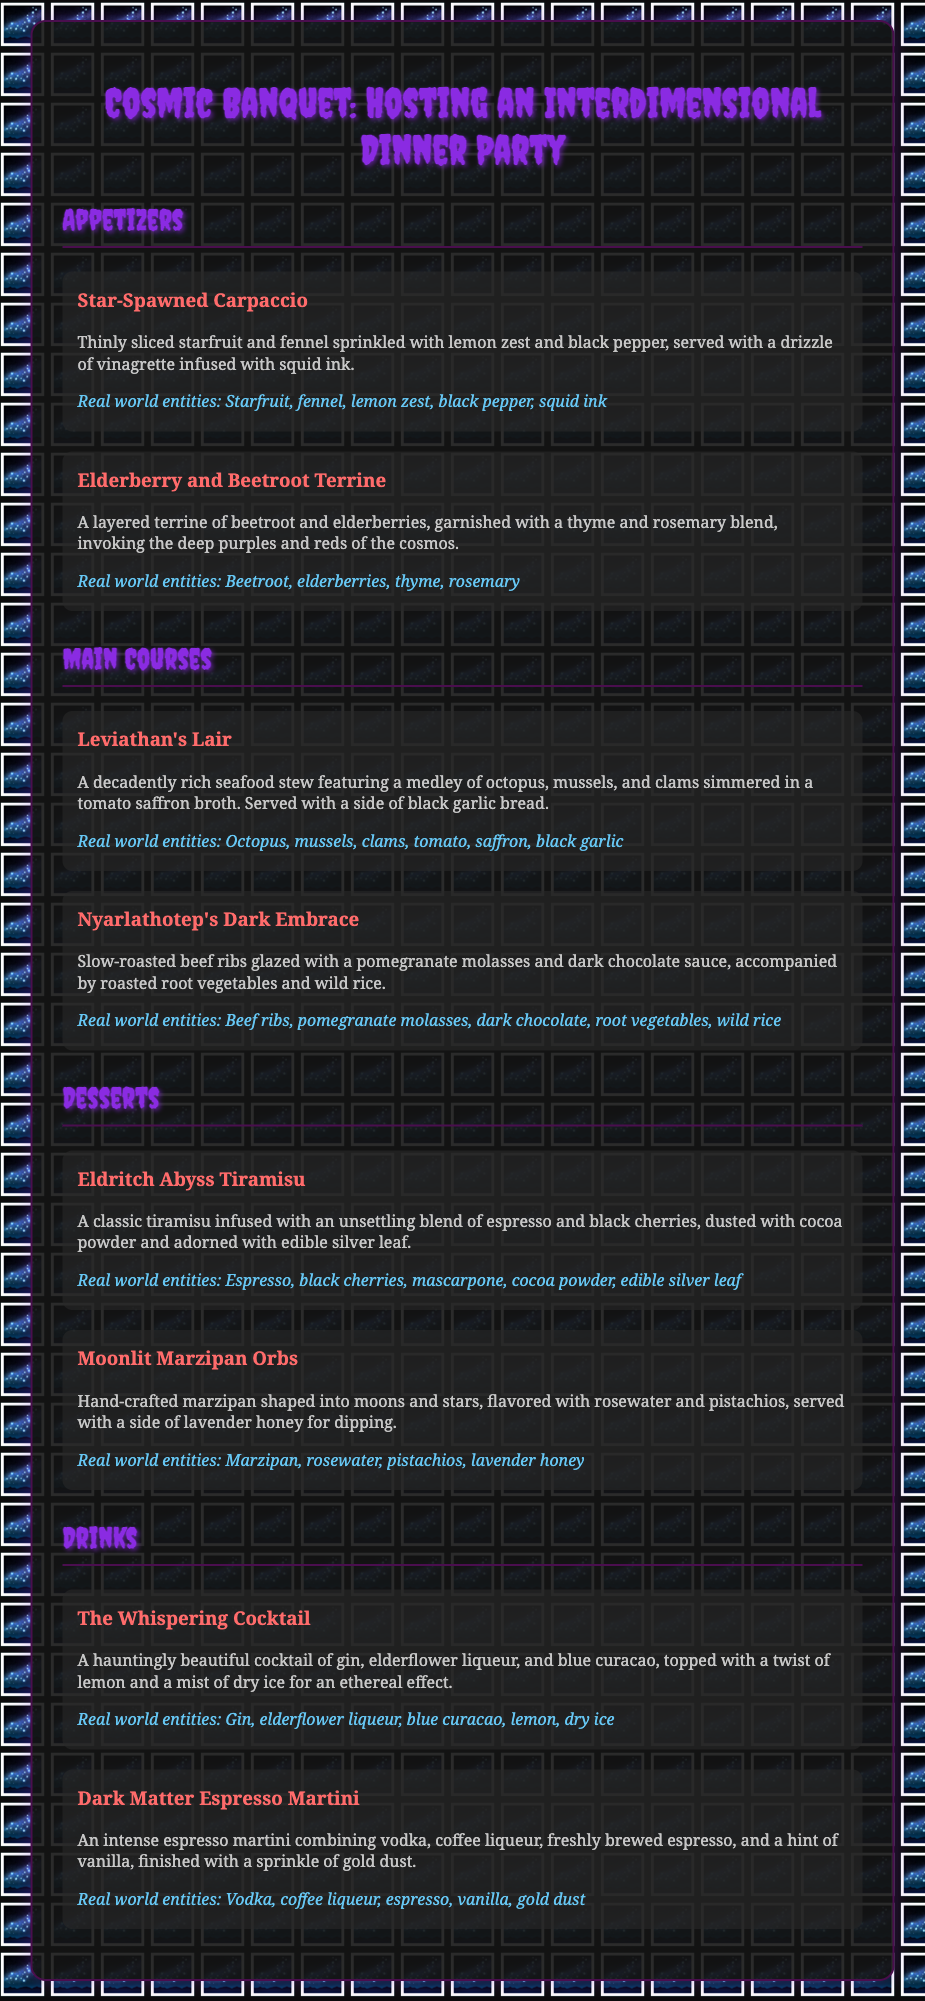What is the title of the document? The title of the document is presented at the top of the rendered view as the main heading.
Answer: Cosmic Banquet: Hosting an Interdimensional Dinner Party How many appetizers are listed in the document? There are two courses under the Appetizers section, which are detailed in the document.
Answer: 2 What is the main ingredient in Leviathan's Lair? The dish Leviathan's Lair prominently features seafood, specifically mentioned in the description.
Answer: Seafood Which dessert includes edible silver leaf? The ingredient edible silver leaf is specifically mentioned in the description of one of the dessert courses.
Answer: Eldritch Abyss Tiramisu What type of cocktail is The Whispering Cocktail? The description elaborates on the ingredients and effects of the drink, indicating its category.
Answer: Cocktail How is the Elderberry and Beetroot Terrine garnished? The document states that the terrine is garnished with a specific blend of herbs that provide detail on its presentation.
Answer: Thyme and rosemary blend What flavors are found in the Moonlit Marzipan Orbs? The flavors mentioned in the description highlight the components that characterize the dish.
Answer: Rosewater and pistachios What drink features dry ice? The document mentions dry ice as part of the presentation for a specific drink, indicating its unique feature.
Answer: The Whispering Cocktail 